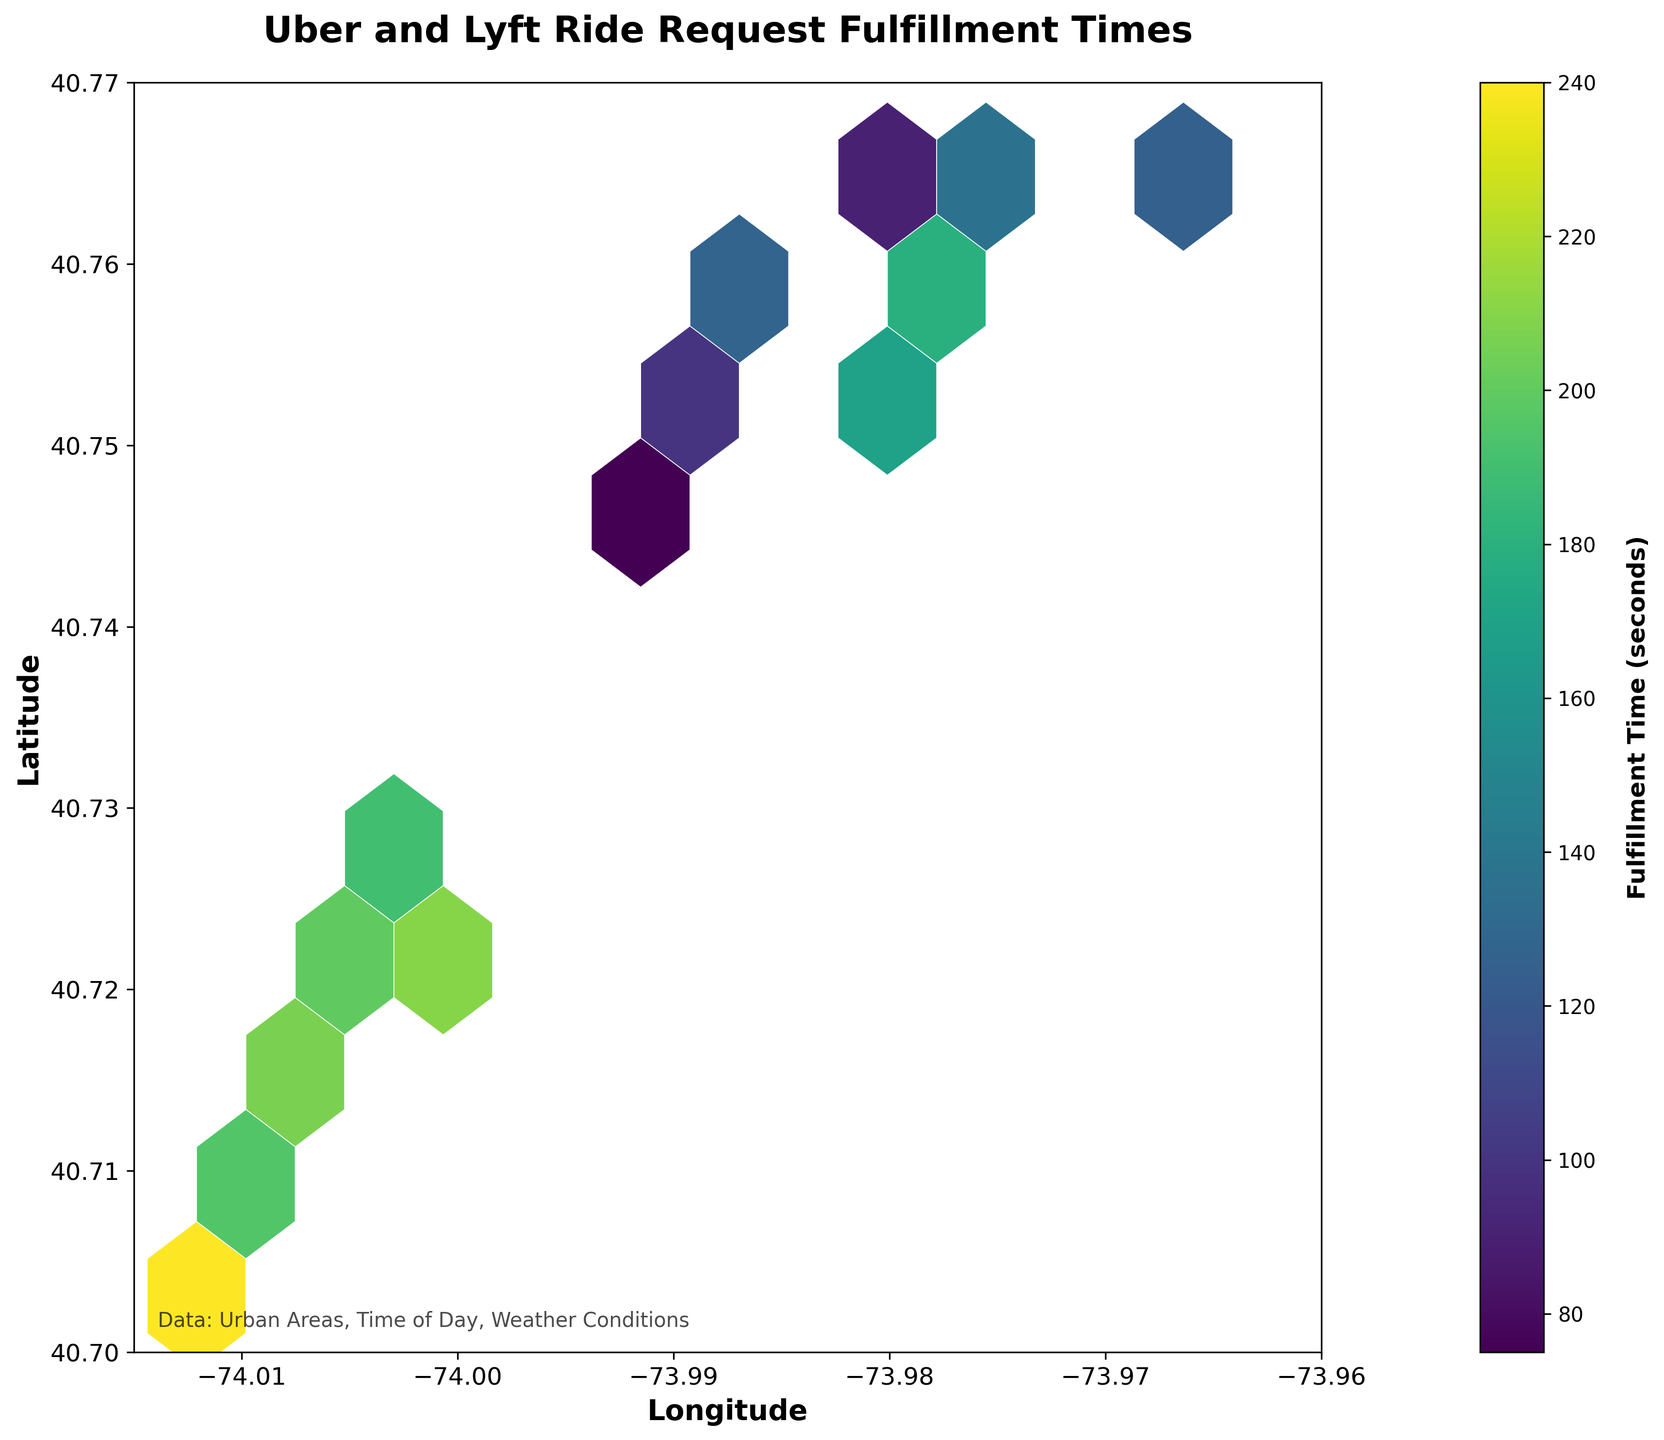What's the title of the plot? The title is clearly displayed at the top center of the plot.
Answer: Uber and Lyft Ride Request Fulfillment Times What do the colors in the hexagons represent? The color intensity in the hexagons represents the fulfillment time in seconds, with the legend (color bar) indicating the mapping between color and time.
Answer: Fulfillment time (seconds) What's the range of fulfillment times represented in the color bar? By looking at the start and end of the color bar labels, we can see the range of values it represents.
Answer: 75 to 240 seconds Which longitude range is represented on the x-axis? The x-axis labels show the range of longitudes covered by the plot.
Answer: -74.015 to -73.96 Which latitude range is represented on the y-axis? The y-axis labels show the range of latitudes covered by the plot.
Answer: 40.70 to 40.77 Which urban area has the highest fulfillment time? The hexagon with the most intense color (darkest) represents the highest fulfillment time, and its location can be pinpointed to a specific urban area using the x (longitude) and y (latitude) ranges.
Answer: (40.7031, -74.0121) Which urban area has the lowest fulfillment time? The hexagon with the least intense color (lightest) represents the lowest fulfillment time, and its location can be pinpointed using the x (longitude) and y (latitude) ranges.
Answer: (40.7484, -73.9936) How many areas have fulfillment times over 200 seconds? By looking at the hexagons with colors corresponding to the upper range of the color bar, we count how many hexagons represent fulfillment times over 200 seconds.
Answer: 4 Compare the fulfillment times at (40.7128, -74.0060) and (40.7529, -73.9887). Which one is higher? Locate the fulfillment times using the color of the corresponding hexagons and compare them directly.
Answer: (40.7128, -74.0060) with 180 seconds is higher Is there any data point at the lower left corner of the plot? Check the lower left corner of the x and y axes to see if there is any hexagon present.
Answer: No Which area has a fulfillment time of exactly 100 seconds? By identifying the hexagon color that matches 100 seconds on the color bar and pinpoint its location using x and y coordinates.
Answer: (40.7631, -73.9679) 